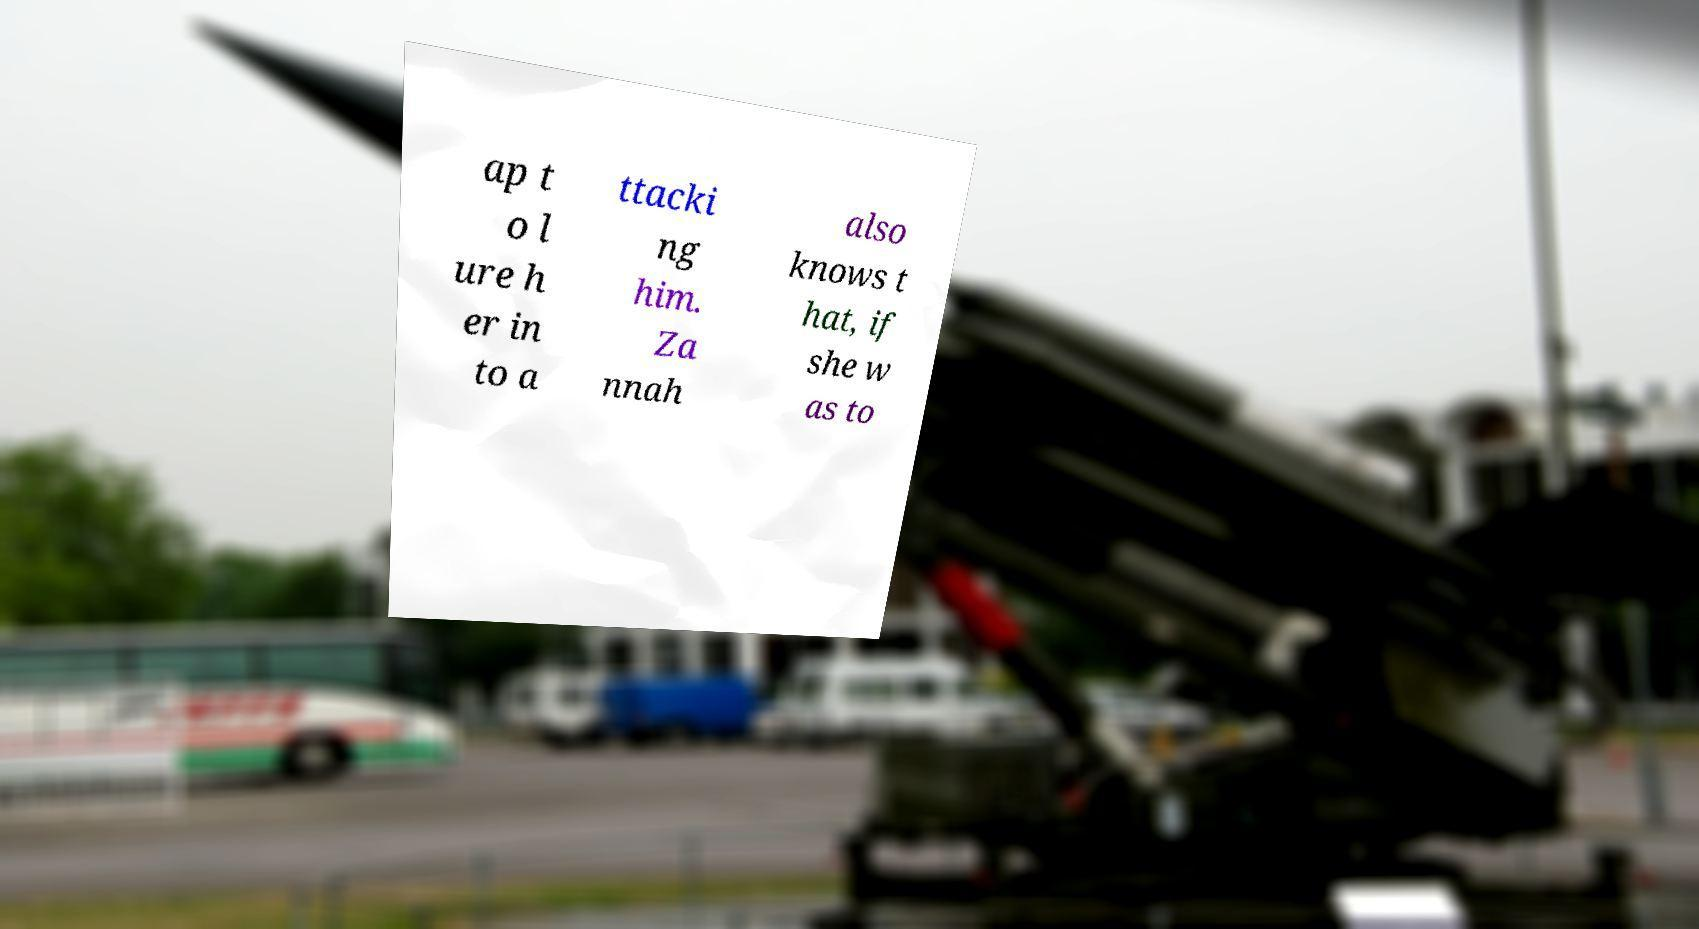Can you accurately transcribe the text from the provided image for me? ap t o l ure h er in to a ttacki ng him. Za nnah also knows t hat, if she w as to 